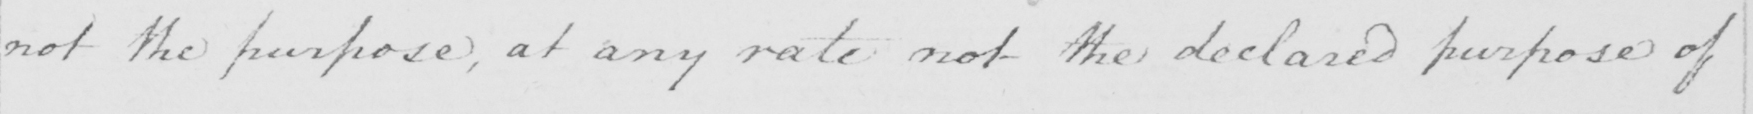Please transcribe the handwritten text in this image. not the purpose , at any rate not the declared purpose of 